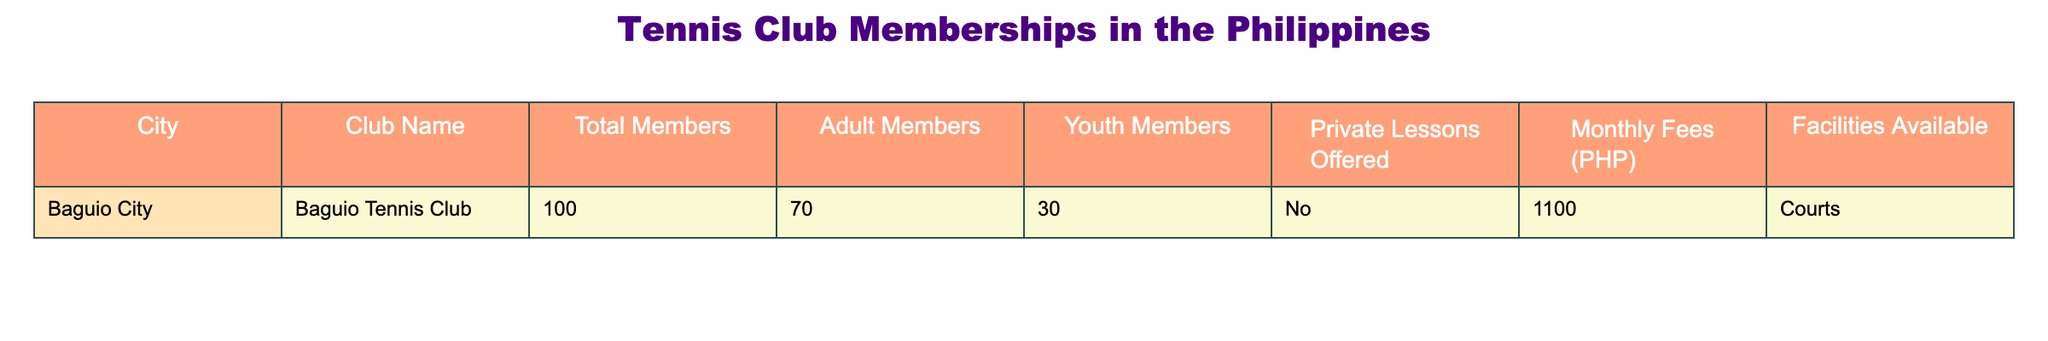What is the total number of members at the Baguio Tennis Club? The table shows that the total members at the Baguio Tennis Club is listed under the "Total Members" column, which is 100.
Answer: 100 How many adult members are there at the Baguio Tennis Club? Referring to the "Adult Members" column for the Baguio Tennis Club, it indicates there are 70 adult members.
Answer: 70 Is there a private lesson offered at the Baguio Tennis Club? The "Private Lessons Offered" column shows "No," indicating that there are no private lessons available at this club.
Answer: No What percentage of the members are youth members at the Baguio Tennis Club? The number of youth members is 30, and the total members are 100. The percentage is calculated as (30/100) * 100 = 30%.
Answer: 30% What is the difference between adult members and youth members at the Baguio Tennis Club? The number of adult members is 70 and the number of youth members is 30. The difference is calculated as 70 - 30 = 40.
Answer: 40 If a member pays the monthly fee, how much will they spend in a year? The monthly fee is 1100 PHP. Over 12 months, the total amount spent would be 1100 * 12 = 13200 PHP.
Answer: 13200 PHP How many total members would there be if all youth members become adult members at the Baguio Tennis Club? If all 30 youth members were to become adult members, the new total would be the sum of the current adult members (70) and youth members (30), resulting in 100 total members.
Answer: 100 Is the number of youth members at the Baguio Tennis Club greater than the number of adult members? The youth members are 30, and the adult members are 70, therefore the statement is false since 30 is less than 70.
Answer: No What are the total facilities available at the Baguio Tennis Club? The table indicates that the facilities available at the Baguio Tennis Club are "Courts." That is the only facility listed.
Answer: Courts If the club increased its membership by 50 members, what would the new total number of members be? The current total number of members is 100. Adding 50 members would result in a new total of 100 + 50 = 150 members.
Answer: 150 